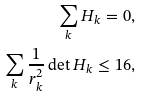<formula> <loc_0><loc_0><loc_500><loc_500>\sum _ { k } H _ { k } = 0 , \\ \sum _ { k } \frac { 1 } { r _ { k } ^ { 2 } } \det H _ { k } \leq 1 6 ,</formula> 